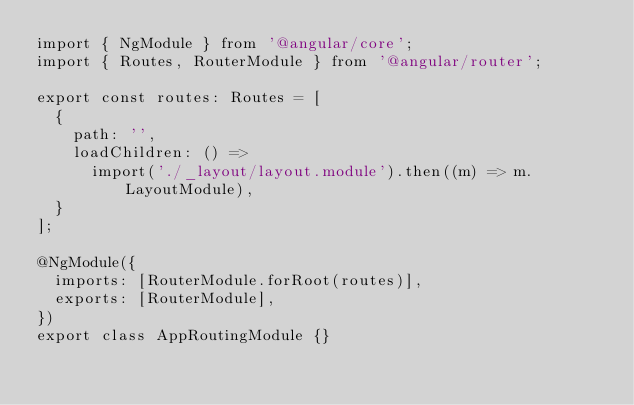<code> <loc_0><loc_0><loc_500><loc_500><_TypeScript_>import { NgModule } from '@angular/core';
import { Routes, RouterModule } from '@angular/router';

export const routes: Routes = [
  {
    path: '',
    loadChildren: () =>
      import('./_layout/layout.module').then((m) => m.LayoutModule),
  }
];

@NgModule({
  imports: [RouterModule.forRoot(routes)],
  exports: [RouterModule],
})
export class AppRoutingModule {}
</code> 